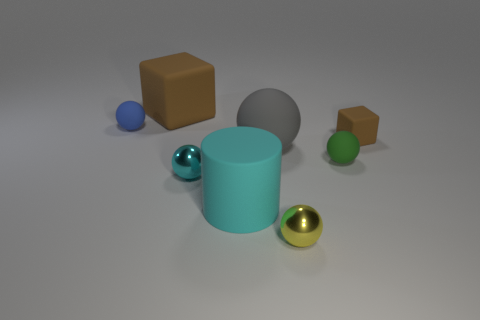What is the material of the other cube that is the same color as the big cube?
Ensure brevity in your answer.  Rubber. What number of metallic things are either yellow cylinders or tiny blue spheres?
Give a very brief answer. 0. What shape is the small brown matte thing?
Ensure brevity in your answer.  Cube. How many large brown things have the same material as the tiny brown thing?
Your answer should be compact. 1. The large sphere that is made of the same material as the green thing is what color?
Make the answer very short. Gray. Does the brown thing left of the gray rubber object have the same size as the tiny brown matte object?
Give a very brief answer. No. There is a large object that is the same shape as the tiny yellow shiny thing; what is its color?
Keep it short and to the point. Gray. What is the shape of the big object that is behind the tiny matte sphere left of the brown matte cube to the left of the yellow ball?
Offer a terse response. Cube. Is the big cyan rubber object the same shape as the blue object?
Provide a short and direct response. No. There is a small matte object behind the rubber cube in front of the blue sphere; what shape is it?
Provide a short and direct response. Sphere. 